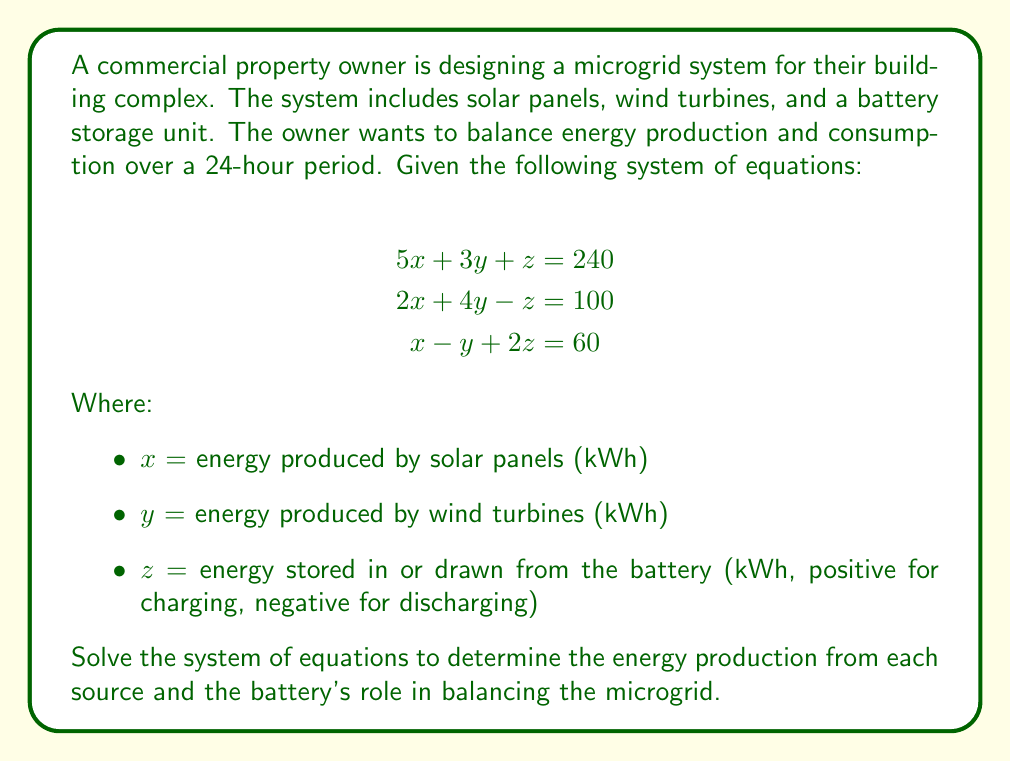Solve this math problem. To solve this system of equations, we'll use the Gaussian elimination method:

1) First, let's write the augmented matrix:

$$\begin{bmatrix}
5 & 3 & 1 & 240 \\
2 & 4 & -1 & 100 \\
1 & -1 & 2 & 60
\end{bmatrix}$$

2) Multiply the first row by -2/5 and add it to the second row:

$$\begin{bmatrix}
5 & 3 & 1 & 240 \\
0 & \frac{14}{5} & -\frac{7}{5} & 4 \\
1 & -1 & 2 & 60
\end{bmatrix}$$

3) Multiply the first row by -1/5 and add it to the third row:

$$\begin{bmatrix}
5 & 3 & 1 & 240 \\
0 & \frac{14}{5} & -\frac{7}{5} & 4 \\
0 & -\frac{8}{5} & \frac{9}{5} & 12
\end{bmatrix}$$

4) Multiply the second row by 8/14 and add it to the third row:

$$\begin{bmatrix}
5 & 3 & 1 & 240 \\
0 & \frac{14}{5} & -\frac{7}{5} & 4 \\
0 & 0 & \frac{47}{35} & \frac{116}{5}
\end{bmatrix}$$

5) Now we have an upper triangular matrix. We can solve for z:

$\frac{47}{35}z = \frac{116}{5}$
$z = \frac{116 * 35}{5 * 47} = \frac{812}{235} \approx 3.45$

6) Substitute z back into the second equation:

$\frac{14}{5}y - \frac{7}{5}(\frac{812}{235}) = 4$
$\frac{14}{5}y = 4 + \frac{5684}{1175} = \frac{10434}{1175}$
$y = \frac{10434}{3290} \approx 3.17$

7) Finally, substitute y and z into the first equation:

$5x + 3(\frac{10434}{3290}) + \frac{812}{235} = 240$
$5x = 240 - \frac{31302}{3290} - \frac{812}{235} = \frac{218930}{3290}$
$x = \frac{43786}{3290} \approx 13.31$
Answer: The solution to the system of equations is:

$x \approx 13.31$ kWh (solar panel production)
$y \approx 3.17$ kWh (wind turbine production)
$z \approx 3.45$ kWh (battery charging)

This means the solar panels produce about 13.31 kWh, the wind turbines produce about 3.17 kWh, and the battery stores about 3.45 kWh of excess energy to balance the microgrid over the 24-hour period. 